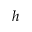Convert formula to latex. <formula><loc_0><loc_0><loc_500><loc_500>h</formula> 